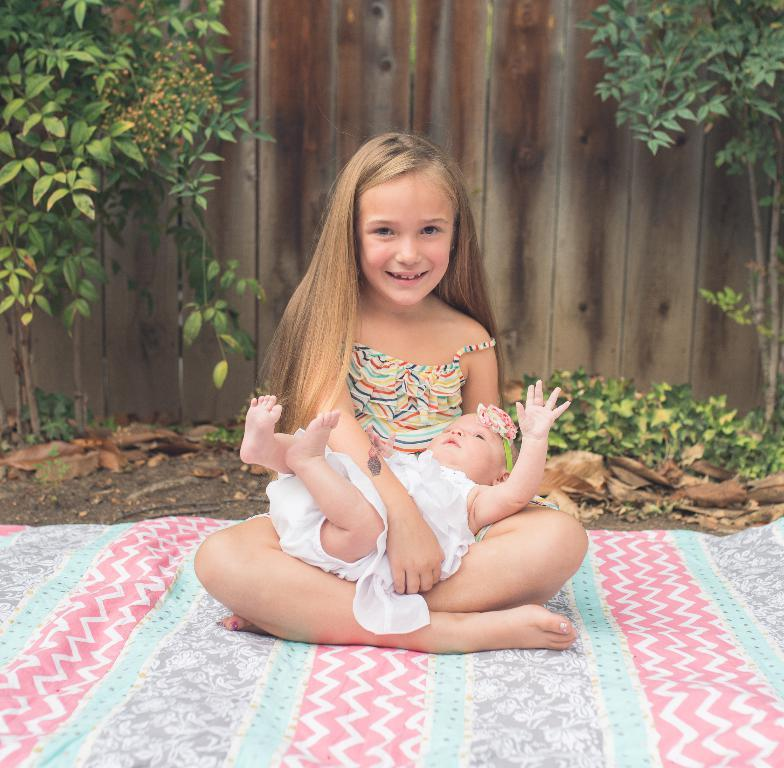What is the girl in the image doing? The girl is holding a baby in the image. What can be seen at the bottom of the image? There is a bed sheet visible at the bottom of the image. What is visible in the background of the image? There are trees, plants, and a wooden wall in the background of the image. What type of support can be seen in the image for the baby to play on? There is no support for the baby to play on in the image; the girl is simply holding the baby. What type of bushes are present in the background of the image? There are no bushes present in the image; only trees and plants are visible in the background. 